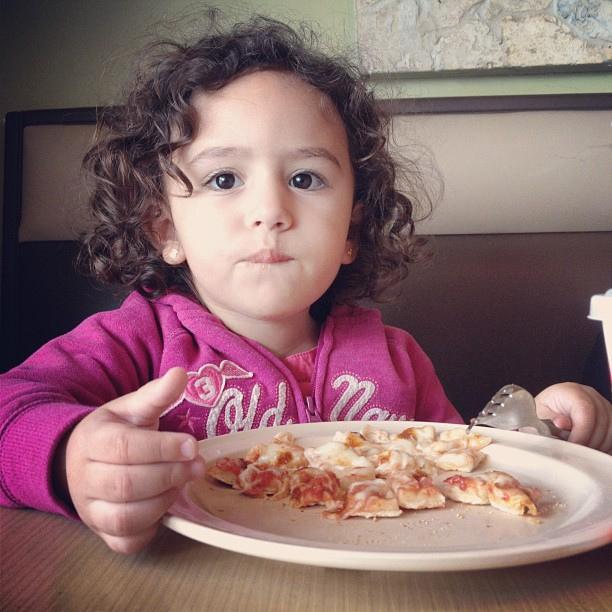Is the girl enjoying what she's eating?
Answer briefly. Yes. Is there mushroom on the pizza?
Write a very short answer. No. What is his food inside of?
Give a very brief answer. Plate. Is the child's hair in the picture straight or curly?
Quick response, please. Curly. Is she sitting still?
Keep it brief. Yes. Is she sharing her dinner with a cat?
Keep it brief. No. Is the baby a blonde or brunette?
Concise answer only. Brunette. Is the person eating over 18 years old?
Quick response, please. No. Does the girl have bangs?
Write a very short answer. No. What is the brand of sweatshirt the little girl is wearing?
Quick response, please. Old navy. What is the girl doing with her hand?
Short answer required. Holding fork. Is here hair curly?
Be succinct. Yes. What is on the wrist?
Be succinct. Nothing. Why is the pizza cut into small pieces?
Concise answer only. Yes. Is the baby looking at the pizza?
Write a very short answer. No. Are there veggies?
Be succinct. No. Are there flowers?
Short answer required. No. What color is the plate?
Answer briefly. White. What color is his shirt?
Give a very brief answer. Pink. What does she have in her mouth?
Short answer required. Pizza. What expression is on the little girl's face?
Give a very brief answer. Happy. Is there a napkin on the table?
Be succinct. No. What facial expression does the girl have?
Quick response, please. None. Is this baby eating?
Write a very short answer. Yes. Does the child look happy?
Give a very brief answer. No. Is the meal healthy?
Short answer required. No. 